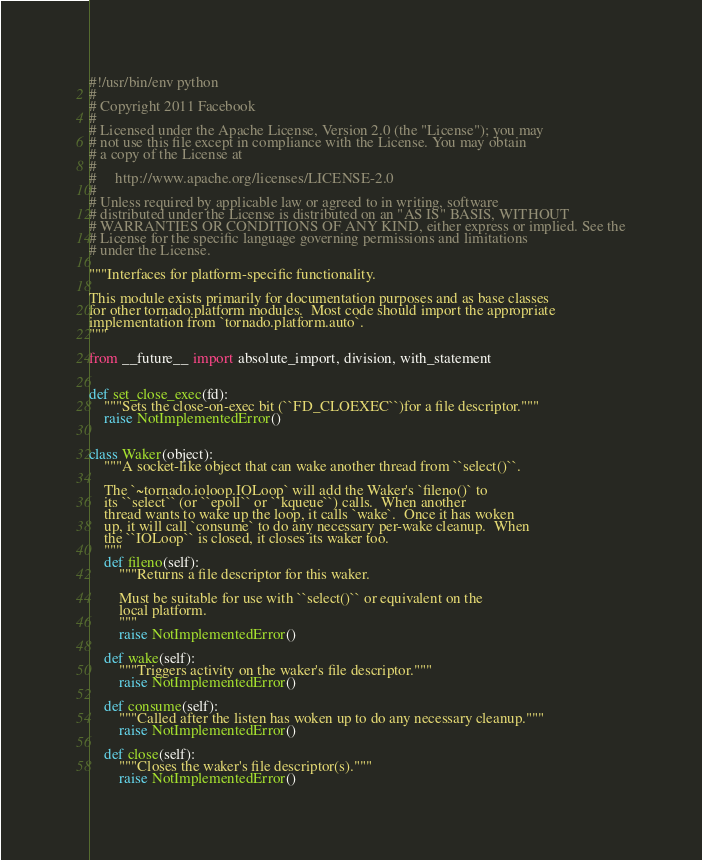<code> <loc_0><loc_0><loc_500><loc_500><_Python_>#!/usr/bin/env python
#
# Copyright 2011 Facebook
#
# Licensed under the Apache License, Version 2.0 (the "License"); you may
# not use this file except in compliance with the License. You may obtain
# a copy of the License at
#
#     http://www.apache.org/licenses/LICENSE-2.0
#
# Unless required by applicable law or agreed to in writing, software
# distributed under the License is distributed on an "AS IS" BASIS, WITHOUT
# WARRANTIES OR CONDITIONS OF ANY KIND, either express or implied. See the
# License for the specific language governing permissions and limitations
# under the License.

"""Interfaces for platform-specific functionality.

This module exists primarily for documentation purposes and as base classes
for other tornado.platform modules.  Most code should import the appropriate
implementation from `tornado.platform.auto`.
"""

from __future__ import absolute_import, division, with_statement


def set_close_exec(fd):
    """Sets the close-on-exec bit (``FD_CLOEXEC``)for a file descriptor."""
    raise NotImplementedError()


class Waker(object):
    """A socket-like object that can wake another thread from ``select()``.

    The `~tornado.ioloop.IOLoop` will add the Waker's `fileno()` to
    its ``select`` (or ``epoll`` or ``kqueue``) calls.  When another
    thread wants to wake up the loop, it calls `wake`.  Once it has woken
    up, it will call `consume` to do any necessary per-wake cleanup.  When
    the ``IOLoop`` is closed, it closes its waker too.
    """
    def fileno(self):
        """Returns a file descriptor for this waker.

        Must be suitable for use with ``select()`` or equivalent on the
        local platform.
        """
        raise NotImplementedError()

    def wake(self):
        """Triggers activity on the waker's file descriptor."""
        raise NotImplementedError()

    def consume(self):
        """Called after the listen has woken up to do any necessary cleanup."""
        raise NotImplementedError()

    def close(self):
        """Closes the waker's file descriptor(s)."""
        raise NotImplementedError()
</code> 